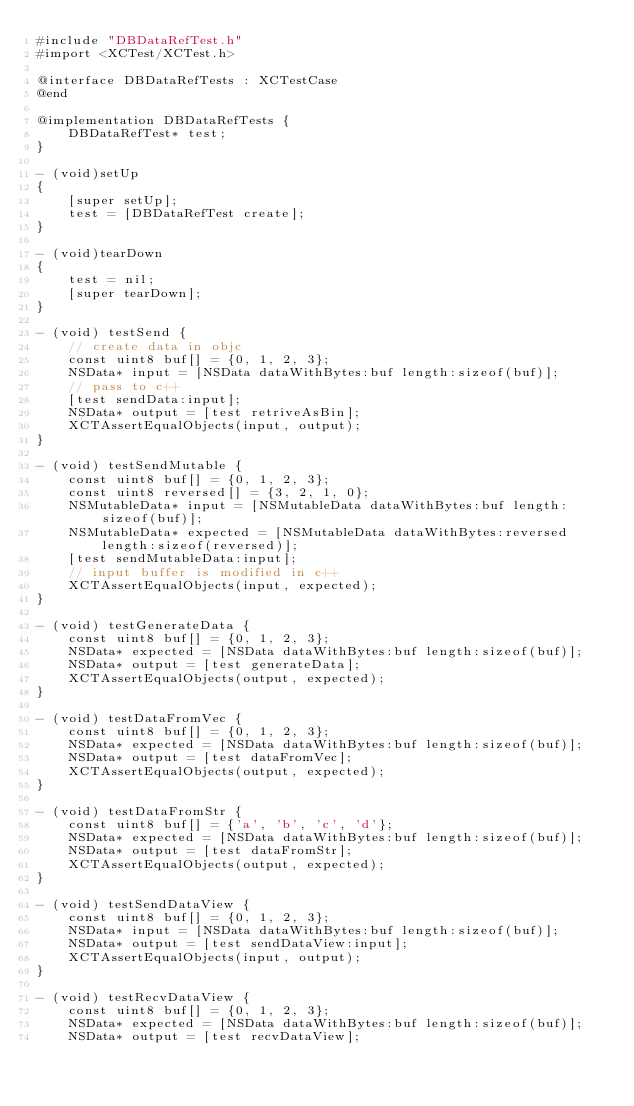Convert code to text. <code><loc_0><loc_0><loc_500><loc_500><_ObjectiveC_>#include "DBDataRefTest.h"
#import <XCTest/XCTest.h>

@interface DBDataRefTests : XCTestCase
@end

@implementation DBDataRefTests {
    DBDataRefTest* test;
}

- (void)setUp
{
    [super setUp];
    test = [DBDataRefTest create];
}

- (void)tearDown
{
    test = nil;
    [super tearDown];
}

- (void) testSend {
    // create data in objc
    const uint8 buf[] = {0, 1, 2, 3};
    NSData* input = [NSData dataWithBytes:buf length:sizeof(buf)];
    // pass to c++
    [test sendData:input];
    NSData* output = [test retriveAsBin];
    XCTAssertEqualObjects(input, output);
}

- (void) testSendMutable {
    const uint8 buf[] = {0, 1, 2, 3};
    const uint8 reversed[] = {3, 2, 1, 0};
    NSMutableData* input = [NSMutableData dataWithBytes:buf length:sizeof(buf)];
    NSMutableData* expected = [NSMutableData dataWithBytes:reversed length:sizeof(reversed)];
    [test sendMutableData:input];
    // input buffer is modified in c++
    XCTAssertEqualObjects(input, expected);
}

- (void) testGenerateData {
    const uint8 buf[] = {0, 1, 2, 3};
    NSData* expected = [NSData dataWithBytes:buf length:sizeof(buf)];
    NSData* output = [test generateData];
    XCTAssertEqualObjects(output, expected);
}

- (void) testDataFromVec {
    const uint8 buf[] = {0, 1, 2, 3};
    NSData* expected = [NSData dataWithBytes:buf length:sizeof(buf)];
    NSData* output = [test dataFromVec];
    XCTAssertEqualObjects(output, expected);
}

- (void) testDataFromStr {
    const uint8 buf[] = {'a', 'b', 'c', 'd'};
    NSData* expected = [NSData dataWithBytes:buf length:sizeof(buf)];
    NSData* output = [test dataFromStr];
    XCTAssertEqualObjects(output, expected);
}

- (void) testSendDataView {
    const uint8 buf[] = {0, 1, 2, 3};
    NSData* input = [NSData dataWithBytes:buf length:sizeof(buf)];
    NSData* output = [test sendDataView:input];
    XCTAssertEqualObjects(input, output);
}

- (void) testRecvDataView {
    const uint8 buf[] = {0, 1, 2, 3};
    NSData* expected = [NSData dataWithBytes:buf length:sizeof(buf)];
    NSData* output = [test recvDataView];</code> 